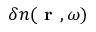Convert formula to latex. <formula><loc_0><loc_0><loc_500><loc_500>\delta n ( r , \omega )</formula> 